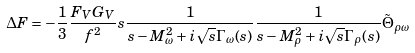Convert formula to latex. <formula><loc_0><loc_0><loc_500><loc_500>\Delta F = - \frac { 1 } { 3 } \frac { F _ { V } G _ { V } } { f ^ { 2 } } s \frac { 1 } { s - M _ { \omega } ^ { 2 } + i \sqrt { s } \Gamma _ { \omega } ( s ) } \frac { 1 } { s - M _ { \rho } ^ { 2 } + i \sqrt { s } \Gamma _ { \rho } ( s ) } \tilde { \Theta } _ { \rho \omega }</formula> 